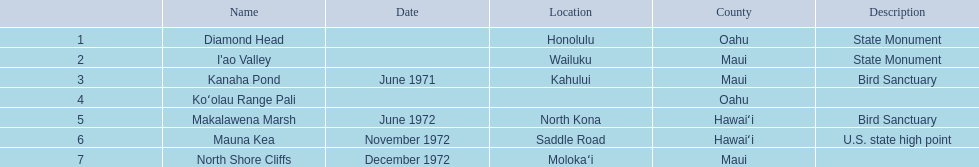What are all of the landmark names? Diamond Head, I'ao Valley, Kanaha Pond, Koʻolau Range Pali, Makalawena Marsh, Mauna Kea, North Shore Cliffs. Where are they located? Honolulu, Wailuku, Kahului, , North Kona, Saddle Road, Molokaʻi. And which landmark has no listed location? Koʻolau Range Pali. 